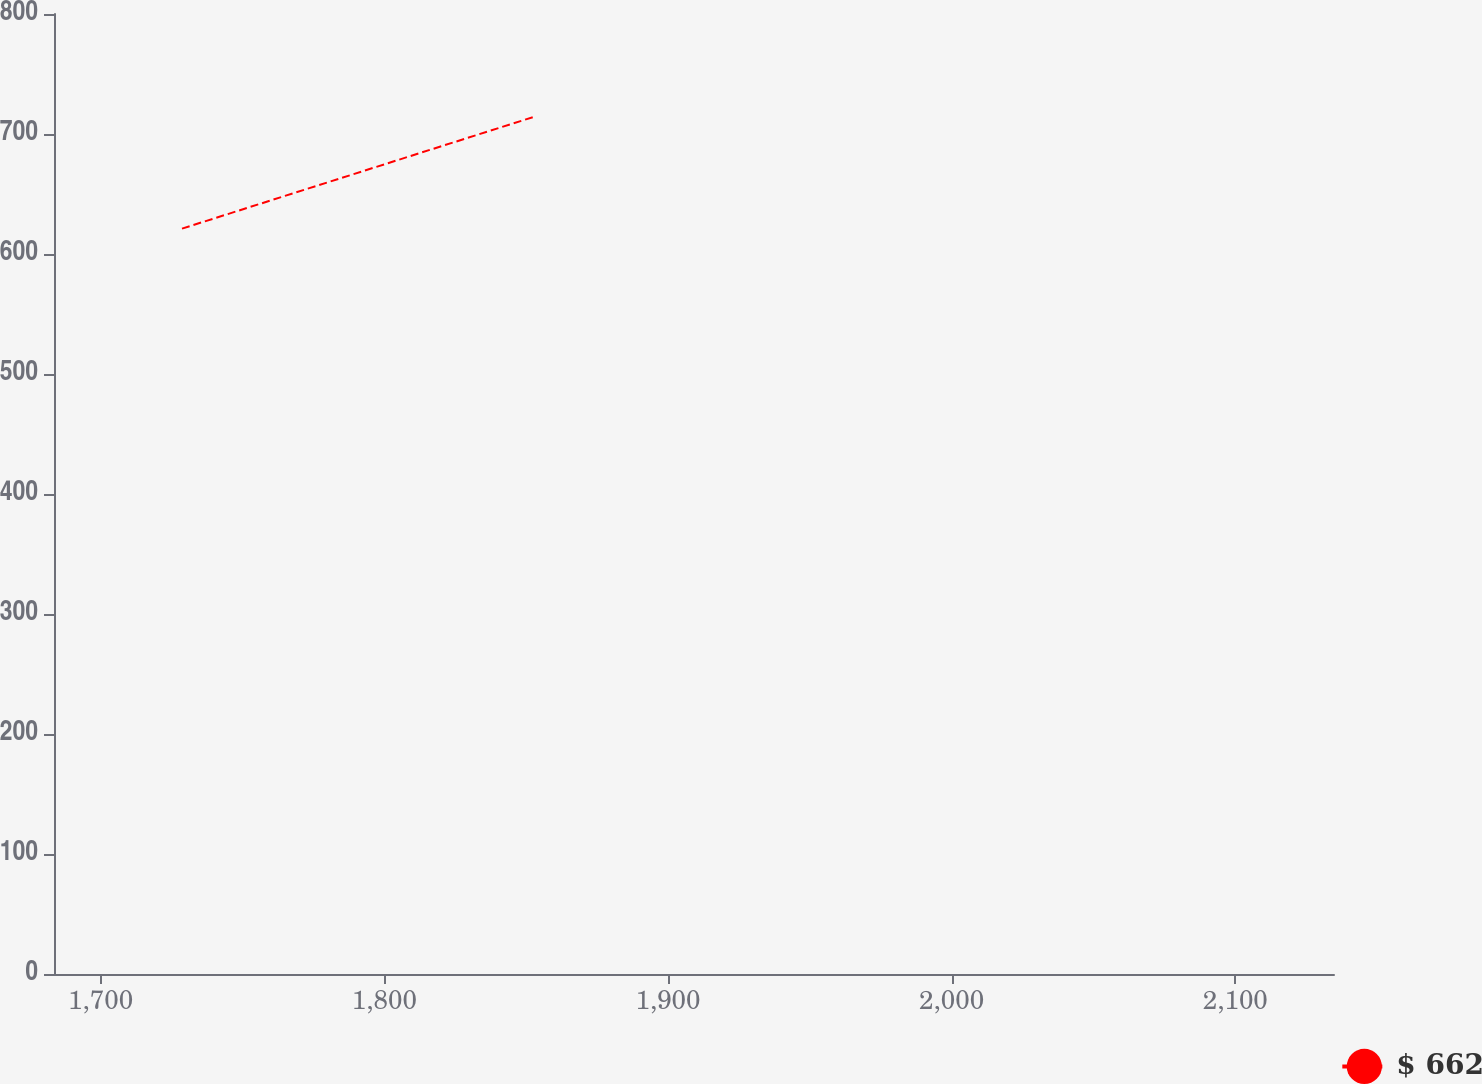<chart> <loc_0><loc_0><loc_500><loc_500><line_chart><ecel><fcel>$ 662<nl><fcel>1728.68<fcel>621.15<nl><fcel>1852.46<fcel>714.1<nl><fcel>2136.72<fcel>679.46<nl><fcel>2179.92<fcel>630.44<nl></chart> 